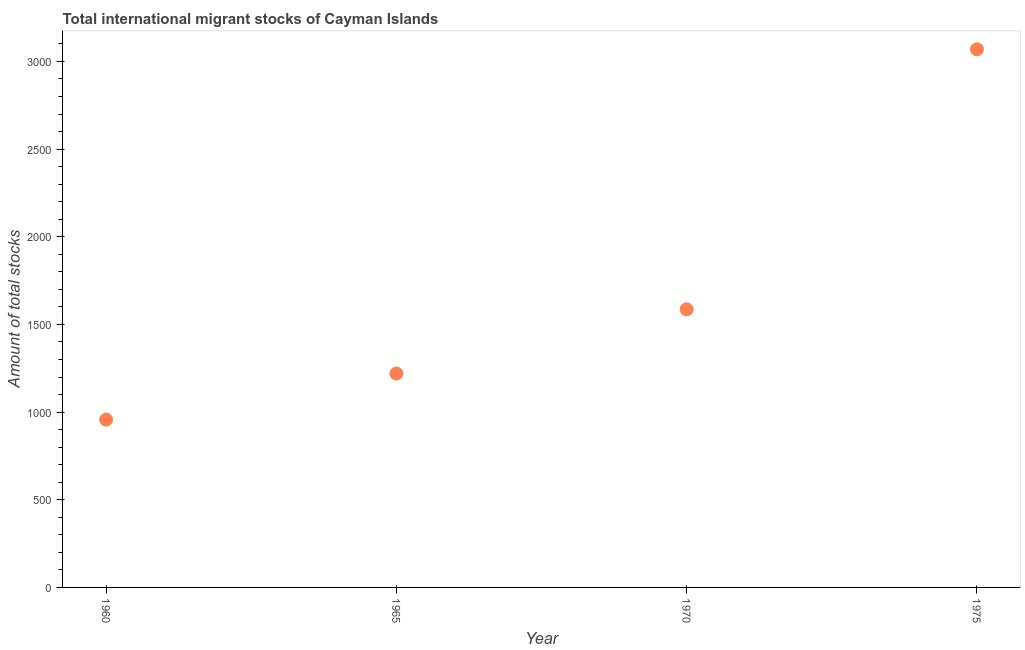What is the total number of international migrant stock in 1965?
Offer a very short reply. 1220. Across all years, what is the maximum total number of international migrant stock?
Your response must be concise. 3069. Across all years, what is the minimum total number of international migrant stock?
Offer a very short reply. 957. In which year was the total number of international migrant stock maximum?
Ensure brevity in your answer.  1975. What is the sum of the total number of international migrant stock?
Give a very brief answer. 6832. What is the difference between the total number of international migrant stock in 1965 and 1975?
Provide a short and direct response. -1849. What is the average total number of international migrant stock per year?
Your answer should be very brief. 1708. What is the median total number of international migrant stock?
Offer a terse response. 1403. Do a majority of the years between 1975 and 1960 (inclusive) have total number of international migrant stock greater than 1200 ?
Your answer should be very brief. Yes. What is the ratio of the total number of international migrant stock in 1965 to that in 1975?
Make the answer very short. 0.4. Is the total number of international migrant stock in 1960 less than that in 1970?
Provide a succinct answer. Yes. What is the difference between the highest and the second highest total number of international migrant stock?
Give a very brief answer. 1483. What is the difference between the highest and the lowest total number of international migrant stock?
Give a very brief answer. 2112. In how many years, is the total number of international migrant stock greater than the average total number of international migrant stock taken over all years?
Your answer should be compact. 1. How many dotlines are there?
Make the answer very short. 1. How many years are there in the graph?
Offer a terse response. 4. Does the graph contain any zero values?
Provide a succinct answer. No. Does the graph contain grids?
Your answer should be compact. No. What is the title of the graph?
Your response must be concise. Total international migrant stocks of Cayman Islands. What is the label or title of the X-axis?
Offer a very short reply. Year. What is the label or title of the Y-axis?
Your answer should be very brief. Amount of total stocks. What is the Amount of total stocks in 1960?
Ensure brevity in your answer.  957. What is the Amount of total stocks in 1965?
Provide a succinct answer. 1220. What is the Amount of total stocks in 1970?
Your answer should be very brief. 1586. What is the Amount of total stocks in 1975?
Offer a very short reply. 3069. What is the difference between the Amount of total stocks in 1960 and 1965?
Keep it short and to the point. -263. What is the difference between the Amount of total stocks in 1960 and 1970?
Provide a succinct answer. -629. What is the difference between the Amount of total stocks in 1960 and 1975?
Give a very brief answer. -2112. What is the difference between the Amount of total stocks in 1965 and 1970?
Provide a succinct answer. -366. What is the difference between the Amount of total stocks in 1965 and 1975?
Provide a succinct answer. -1849. What is the difference between the Amount of total stocks in 1970 and 1975?
Provide a short and direct response. -1483. What is the ratio of the Amount of total stocks in 1960 to that in 1965?
Your response must be concise. 0.78. What is the ratio of the Amount of total stocks in 1960 to that in 1970?
Provide a short and direct response. 0.6. What is the ratio of the Amount of total stocks in 1960 to that in 1975?
Give a very brief answer. 0.31. What is the ratio of the Amount of total stocks in 1965 to that in 1970?
Offer a terse response. 0.77. What is the ratio of the Amount of total stocks in 1965 to that in 1975?
Your answer should be compact. 0.4. What is the ratio of the Amount of total stocks in 1970 to that in 1975?
Offer a very short reply. 0.52. 